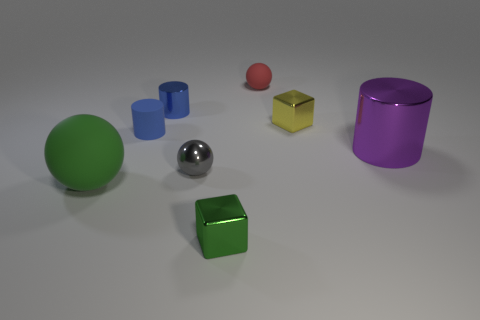Subtract all big metallic cylinders. How many cylinders are left? 2 Add 1 gray metallic things. How many objects exist? 9 Subtract all green cubes. How many blue cylinders are left? 2 Subtract 1 balls. How many balls are left? 2 Subtract all cylinders. How many objects are left? 5 Add 5 matte objects. How many matte objects are left? 8 Add 7 big purple metallic things. How many big purple metallic things exist? 8 Subtract 0 blue blocks. How many objects are left? 8 Subtract all yellow blocks. Subtract all cyan balls. How many blocks are left? 1 Subtract all red rubber balls. Subtract all small shiny blocks. How many objects are left? 5 